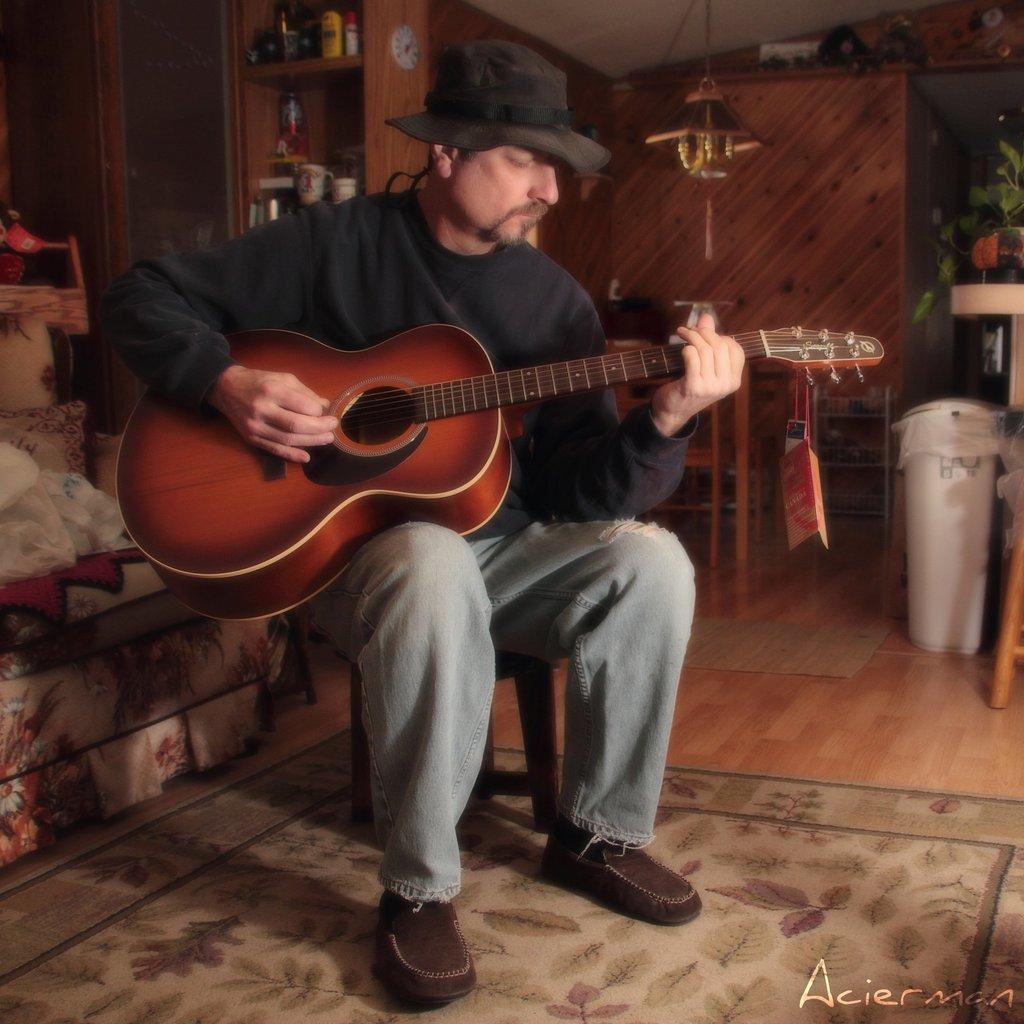How would you summarize this image in a sentence or two? This picture was taken in a house. A person sitting on a chair and playing a guitar, he is wearing black T shirt, torn jeans, brown shoes and a hat. To the left side there is a sofa, on the right side there is a table and plant and the background, there is cupboard and desk filled with the objects. 